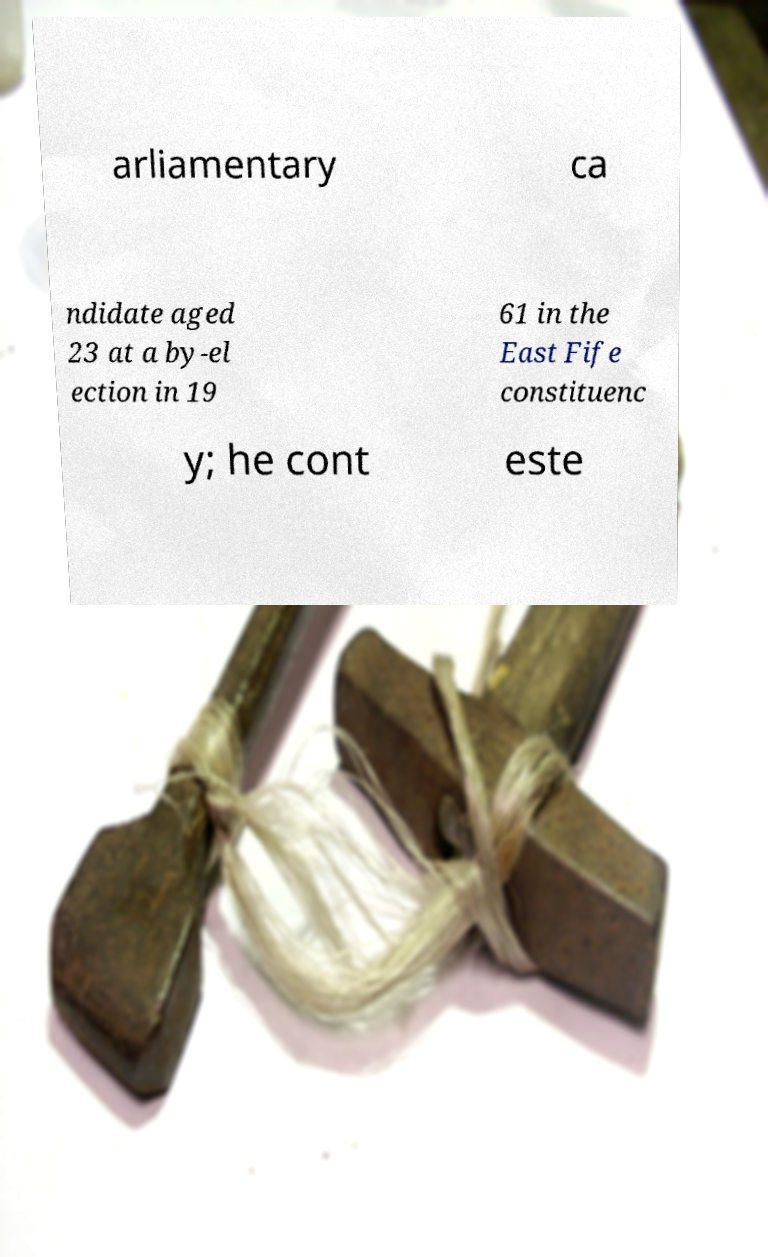Could you extract and type out the text from this image? arliamentary ca ndidate aged 23 at a by-el ection in 19 61 in the East Fife constituenc y; he cont este 